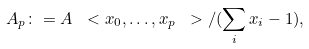Convert formula to latex. <formula><loc_0><loc_0><loc_500><loc_500>A _ { p } \colon = A \ < x _ { 0 } , \dots , x _ { p } \ > / ( \sum _ { i } x _ { i } - 1 ) ,</formula> 